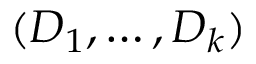Convert formula to latex. <formula><loc_0><loc_0><loc_500><loc_500>( D _ { 1 } , \hdots , D _ { k } )</formula> 